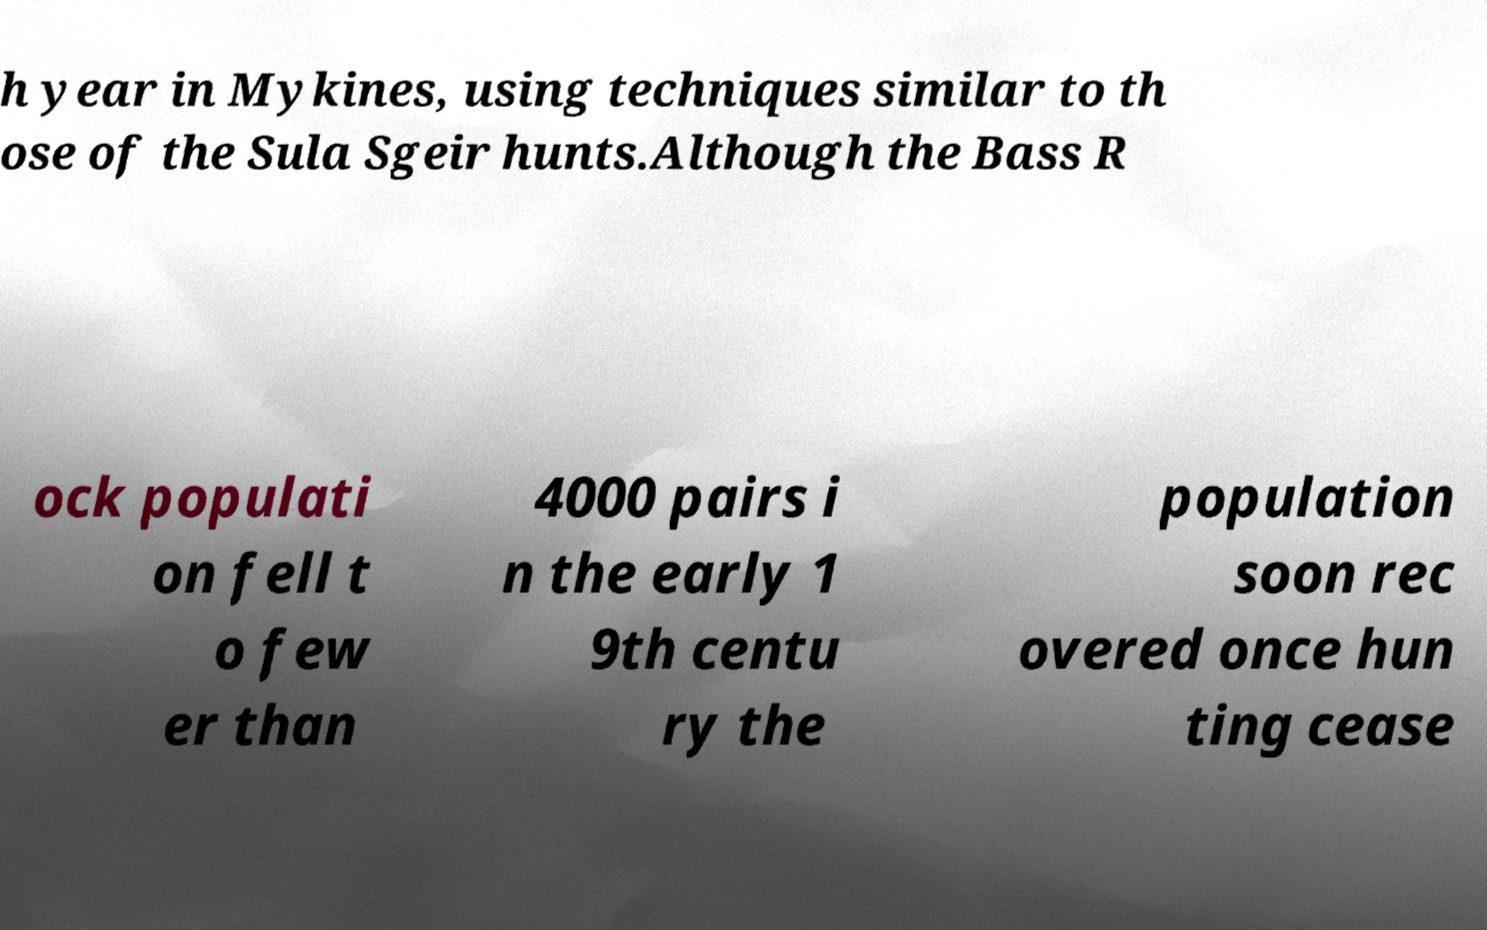For documentation purposes, I need the text within this image transcribed. Could you provide that? h year in Mykines, using techniques similar to th ose of the Sula Sgeir hunts.Although the Bass R ock populati on fell t o few er than 4000 pairs i n the early 1 9th centu ry the population soon rec overed once hun ting cease 